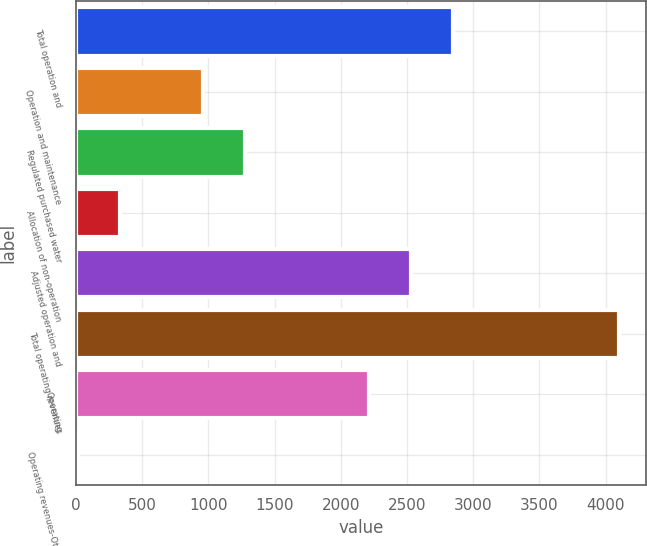<chart> <loc_0><loc_0><loc_500><loc_500><bar_chart><fcel>Total operation and<fcel>Operation and maintenance<fcel>Regulated purchased water<fcel>Allocation of non-operation<fcel>Adjusted operation and<fcel>Total operating revenues<fcel>Operating<fcel>Operating revenues-Other<nl><fcel>2844.9<fcel>960.3<fcel>1274.4<fcel>332.1<fcel>2530.8<fcel>4101.3<fcel>2216.7<fcel>18<nl></chart> 